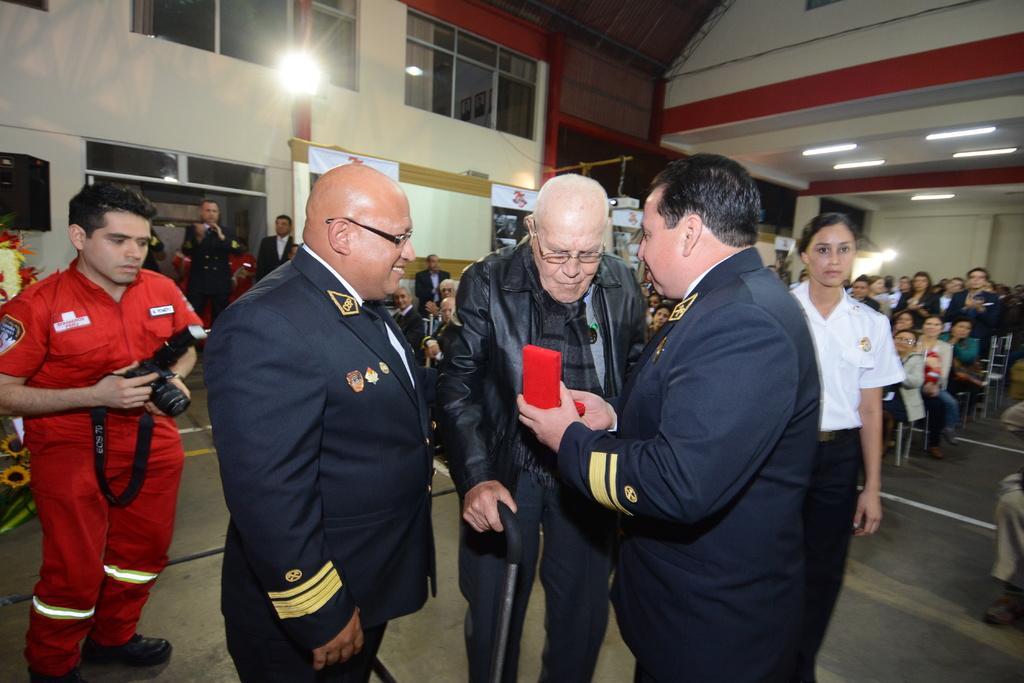Describe this image in one or two sentences. In the foreground of this image, there are three men standing on the floor, a man carrying camera, a woman standing. In the background, there is the crowd sitting, lights to the ceiling and the wall, few posters and flowers on the left. 